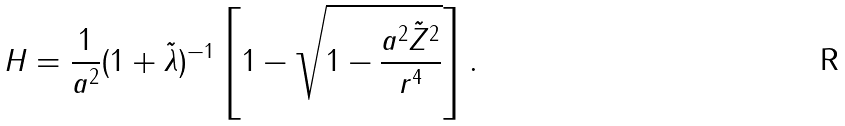<formula> <loc_0><loc_0><loc_500><loc_500>H = \frac { 1 } { a ^ { 2 } } ( 1 + \tilde { \lambda } ) ^ { - 1 } \left [ 1 - \sqrt { 1 - \frac { a ^ { 2 } \tilde { Z } ^ { 2 } } { r ^ { 4 } } } \right ] .</formula> 